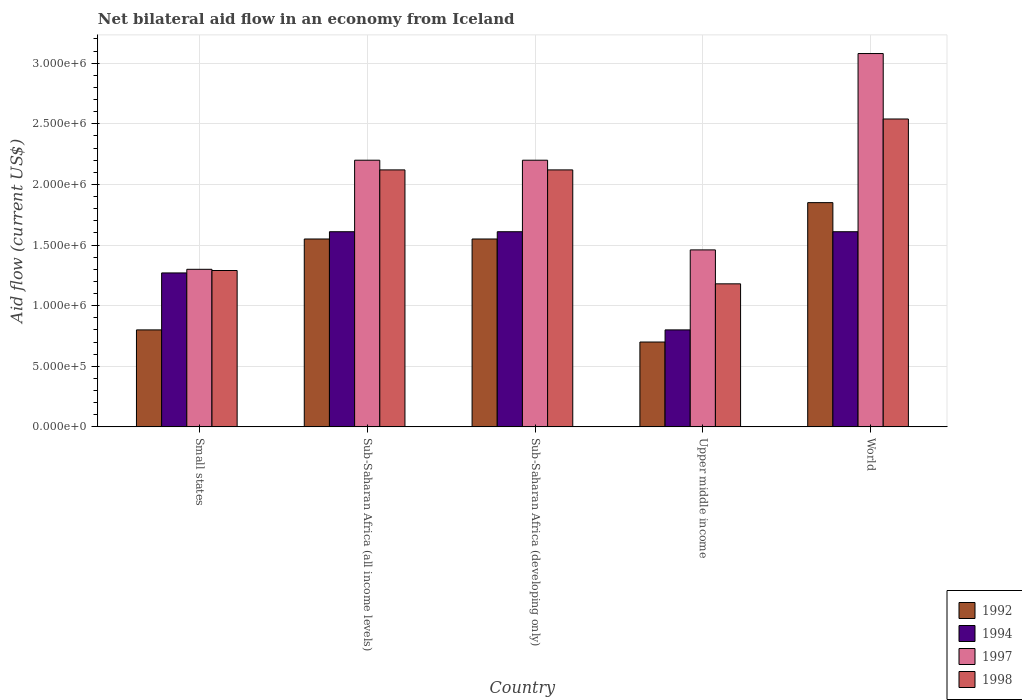How many different coloured bars are there?
Ensure brevity in your answer.  4. How many bars are there on the 4th tick from the left?
Ensure brevity in your answer.  4. What is the label of the 4th group of bars from the left?
Provide a succinct answer. Upper middle income. In how many cases, is the number of bars for a given country not equal to the number of legend labels?
Ensure brevity in your answer.  0. What is the net bilateral aid flow in 1998 in World?
Make the answer very short. 2.54e+06. Across all countries, what is the maximum net bilateral aid flow in 1992?
Offer a very short reply. 1.85e+06. Across all countries, what is the minimum net bilateral aid flow in 1998?
Your answer should be very brief. 1.18e+06. In which country was the net bilateral aid flow in 1997 maximum?
Your response must be concise. World. In which country was the net bilateral aid flow in 1992 minimum?
Your response must be concise. Upper middle income. What is the total net bilateral aid flow in 1998 in the graph?
Offer a very short reply. 9.25e+06. What is the difference between the net bilateral aid flow in 1997 in Sub-Saharan Africa (all income levels) and that in Sub-Saharan Africa (developing only)?
Ensure brevity in your answer.  0. What is the difference between the net bilateral aid flow in 1992 in Sub-Saharan Africa (all income levels) and the net bilateral aid flow in 1998 in Sub-Saharan Africa (developing only)?
Make the answer very short. -5.70e+05. What is the average net bilateral aid flow in 1998 per country?
Offer a terse response. 1.85e+06. What is the difference between the net bilateral aid flow of/in 1998 and net bilateral aid flow of/in 1992 in Sub-Saharan Africa (developing only)?
Your answer should be very brief. 5.70e+05. What is the ratio of the net bilateral aid flow in 1998 in Small states to that in Sub-Saharan Africa (developing only)?
Your response must be concise. 0.61. Is the net bilateral aid flow in 1994 in Upper middle income less than that in World?
Your response must be concise. Yes. What is the difference between the highest and the lowest net bilateral aid flow in 1992?
Give a very brief answer. 1.15e+06. What does the 1st bar from the left in Sub-Saharan Africa (developing only) represents?
Your answer should be compact. 1992. Is it the case that in every country, the sum of the net bilateral aid flow in 1998 and net bilateral aid flow in 1997 is greater than the net bilateral aid flow in 1994?
Give a very brief answer. Yes. Are all the bars in the graph horizontal?
Your answer should be compact. No. Are the values on the major ticks of Y-axis written in scientific E-notation?
Your response must be concise. Yes. How are the legend labels stacked?
Your response must be concise. Vertical. What is the title of the graph?
Your answer should be compact. Net bilateral aid flow in an economy from Iceland. What is the label or title of the X-axis?
Offer a very short reply. Country. What is the Aid flow (current US$) of 1994 in Small states?
Provide a succinct answer. 1.27e+06. What is the Aid flow (current US$) of 1997 in Small states?
Provide a succinct answer. 1.30e+06. What is the Aid flow (current US$) of 1998 in Small states?
Offer a very short reply. 1.29e+06. What is the Aid flow (current US$) of 1992 in Sub-Saharan Africa (all income levels)?
Provide a succinct answer. 1.55e+06. What is the Aid flow (current US$) in 1994 in Sub-Saharan Africa (all income levels)?
Provide a succinct answer. 1.61e+06. What is the Aid flow (current US$) of 1997 in Sub-Saharan Africa (all income levels)?
Your response must be concise. 2.20e+06. What is the Aid flow (current US$) of 1998 in Sub-Saharan Africa (all income levels)?
Your response must be concise. 2.12e+06. What is the Aid flow (current US$) of 1992 in Sub-Saharan Africa (developing only)?
Offer a terse response. 1.55e+06. What is the Aid flow (current US$) of 1994 in Sub-Saharan Africa (developing only)?
Ensure brevity in your answer.  1.61e+06. What is the Aid flow (current US$) of 1997 in Sub-Saharan Africa (developing only)?
Your answer should be very brief. 2.20e+06. What is the Aid flow (current US$) in 1998 in Sub-Saharan Africa (developing only)?
Provide a short and direct response. 2.12e+06. What is the Aid flow (current US$) in 1997 in Upper middle income?
Provide a short and direct response. 1.46e+06. What is the Aid flow (current US$) in 1998 in Upper middle income?
Your answer should be very brief. 1.18e+06. What is the Aid flow (current US$) in 1992 in World?
Your answer should be compact. 1.85e+06. What is the Aid flow (current US$) in 1994 in World?
Ensure brevity in your answer.  1.61e+06. What is the Aid flow (current US$) of 1997 in World?
Keep it short and to the point. 3.08e+06. What is the Aid flow (current US$) of 1998 in World?
Ensure brevity in your answer.  2.54e+06. Across all countries, what is the maximum Aid flow (current US$) of 1992?
Provide a succinct answer. 1.85e+06. Across all countries, what is the maximum Aid flow (current US$) in 1994?
Offer a very short reply. 1.61e+06. Across all countries, what is the maximum Aid flow (current US$) of 1997?
Provide a succinct answer. 3.08e+06. Across all countries, what is the maximum Aid flow (current US$) of 1998?
Make the answer very short. 2.54e+06. Across all countries, what is the minimum Aid flow (current US$) in 1992?
Ensure brevity in your answer.  7.00e+05. Across all countries, what is the minimum Aid flow (current US$) in 1997?
Provide a succinct answer. 1.30e+06. Across all countries, what is the minimum Aid flow (current US$) of 1998?
Offer a very short reply. 1.18e+06. What is the total Aid flow (current US$) in 1992 in the graph?
Offer a very short reply. 6.45e+06. What is the total Aid flow (current US$) of 1994 in the graph?
Provide a short and direct response. 6.90e+06. What is the total Aid flow (current US$) in 1997 in the graph?
Ensure brevity in your answer.  1.02e+07. What is the total Aid flow (current US$) in 1998 in the graph?
Make the answer very short. 9.25e+06. What is the difference between the Aid flow (current US$) in 1992 in Small states and that in Sub-Saharan Africa (all income levels)?
Your response must be concise. -7.50e+05. What is the difference between the Aid flow (current US$) in 1994 in Small states and that in Sub-Saharan Africa (all income levels)?
Your response must be concise. -3.40e+05. What is the difference between the Aid flow (current US$) of 1997 in Small states and that in Sub-Saharan Africa (all income levels)?
Provide a succinct answer. -9.00e+05. What is the difference between the Aid flow (current US$) in 1998 in Small states and that in Sub-Saharan Africa (all income levels)?
Offer a terse response. -8.30e+05. What is the difference between the Aid flow (current US$) in 1992 in Small states and that in Sub-Saharan Africa (developing only)?
Keep it short and to the point. -7.50e+05. What is the difference between the Aid flow (current US$) in 1994 in Small states and that in Sub-Saharan Africa (developing only)?
Your response must be concise. -3.40e+05. What is the difference between the Aid flow (current US$) of 1997 in Small states and that in Sub-Saharan Africa (developing only)?
Your answer should be compact. -9.00e+05. What is the difference between the Aid flow (current US$) of 1998 in Small states and that in Sub-Saharan Africa (developing only)?
Offer a very short reply. -8.30e+05. What is the difference between the Aid flow (current US$) of 1994 in Small states and that in Upper middle income?
Offer a terse response. 4.70e+05. What is the difference between the Aid flow (current US$) in 1997 in Small states and that in Upper middle income?
Provide a short and direct response. -1.60e+05. What is the difference between the Aid flow (current US$) of 1992 in Small states and that in World?
Your response must be concise. -1.05e+06. What is the difference between the Aid flow (current US$) in 1997 in Small states and that in World?
Offer a terse response. -1.78e+06. What is the difference between the Aid flow (current US$) in 1998 in Small states and that in World?
Keep it short and to the point. -1.25e+06. What is the difference between the Aid flow (current US$) of 1992 in Sub-Saharan Africa (all income levels) and that in Sub-Saharan Africa (developing only)?
Make the answer very short. 0. What is the difference between the Aid flow (current US$) in 1994 in Sub-Saharan Africa (all income levels) and that in Sub-Saharan Africa (developing only)?
Offer a very short reply. 0. What is the difference between the Aid flow (current US$) in 1992 in Sub-Saharan Africa (all income levels) and that in Upper middle income?
Your answer should be very brief. 8.50e+05. What is the difference between the Aid flow (current US$) in 1994 in Sub-Saharan Africa (all income levels) and that in Upper middle income?
Your response must be concise. 8.10e+05. What is the difference between the Aid flow (current US$) of 1997 in Sub-Saharan Africa (all income levels) and that in Upper middle income?
Provide a short and direct response. 7.40e+05. What is the difference between the Aid flow (current US$) of 1998 in Sub-Saharan Africa (all income levels) and that in Upper middle income?
Make the answer very short. 9.40e+05. What is the difference between the Aid flow (current US$) in 1997 in Sub-Saharan Africa (all income levels) and that in World?
Ensure brevity in your answer.  -8.80e+05. What is the difference between the Aid flow (current US$) of 1998 in Sub-Saharan Africa (all income levels) and that in World?
Your response must be concise. -4.20e+05. What is the difference between the Aid flow (current US$) in 1992 in Sub-Saharan Africa (developing only) and that in Upper middle income?
Your answer should be compact. 8.50e+05. What is the difference between the Aid flow (current US$) in 1994 in Sub-Saharan Africa (developing only) and that in Upper middle income?
Your answer should be very brief. 8.10e+05. What is the difference between the Aid flow (current US$) in 1997 in Sub-Saharan Africa (developing only) and that in Upper middle income?
Ensure brevity in your answer.  7.40e+05. What is the difference between the Aid flow (current US$) in 1998 in Sub-Saharan Africa (developing only) and that in Upper middle income?
Provide a succinct answer. 9.40e+05. What is the difference between the Aid flow (current US$) in 1992 in Sub-Saharan Africa (developing only) and that in World?
Keep it short and to the point. -3.00e+05. What is the difference between the Aid flow (current US$) of 1994 in Sub-Saharan Africa (developing only) and that in World?
Keep it short and to the point. 0. What is the difference between the Aid flow (current US$) in 1997 in Sub-Saharan Africa (developing only) and that in World?
Keep it short and to the point. -8.80e+05. What is the difference between the Aid flow (current US$) in 1998 in Sub-Saharan Africa (developing only) and that in World?
Your answer should be compact. -4.20e+05. What is the difference between the Aid flow (current US$) of 1992 in Upper middle income and that in World?
Offer a very short reply. -1.15e+06. What is the difference between the Aid flow (current US$) of 1994 in Upper middle income and that in World?
Your answer should be compact. -8.10e+05. What is the difference between the Aid flow (current US$) in 1997 in Upper middle income and that in World?
Provide a short and direct response. -1.62e+06. What is the difference between the Aid flow (current US$) in 1998 in Upper middle income and that in World?
Provide a succinct answer. -1.36e+06. What is the difference between the Aid flow (current US$) of 1992 in Small states and the Aid flow (current US$) of 1994 in Sub-Saharan Africa (all income levels)?
Make the answer very short. -8.10e+05. What is the difference between the Aid flow (current US$) of 1992 in Small states and the Aid flow (current US$) of 1997 in Sub-Saharan Africa (all income levels)?
Keep it short and to the point. -1.40e+06. What is the difference between the Aid flow (current US$) in 1992 in Small states and the Aid flow (current US$) in 1998 in Sub-Saharan Africa (all income levels)?
Offer a very short reply. -1.32e+06. What is the difference between the Aid flow (current US$) of 1994 in Small states and the Aid flow (current US$) of 1997 in Sub-Saharan Africa (all income levels)?
Provide a succinct answer. -9.30e+05. What is the difference between the Aid flow (current US$) in 1994 in Small states and the Aid flow (current US$) in 1998 in Sub-Saharan Africa (all income levels)?
Give a very brief answer. -8.50e+05. What is the difference between the Aid flow (current US$) of 1997 in Small states and the Aid flow (current US$) of 1998 in Sub-Saharan Africa (all income levels)?
Ensure brevity in your answer.  -8.20e+05. What is the difference between the Aid flow (current US$) in 1992 in Small states and the Aid flow (current US$) in 1994 in Sub-Saharan Africa (developing only)?
Ensure brevity in your answer.  -8.10e+05. What is the difference between the Aid flow (current US$) in 1992 in Small states and the Aid flow (current US$) in 1997 in Sub-Saharan Africa (developing only)?
Offer a terse response. -1.40e+06. What is the difference between the Aid flow (current US$) in 1992 in Small states and the Aid flow (current US$) in 1998 in Sub-Saharan Africa (developing only)?
Ensure brevity in your answer.  -1.32e+06. What is the difference between the Aid flow (current US$) of 1994 in Small states and the Aid flow (current US$) of 1997 in Sub-Saharan Africa (developing only)?
Your response must be concise. -9.30e+05. What is the difference between the Aid flow (current US$) in 1994 in Small states and the Aid flow (current US$) in 1998 in Sub-Saharan Africa (developing only)?
Keep it short and to the point. -8.50e+05. What is the difference between the Aid flow (current US$) of 1997 in Small states and the Aid flow (current US$) of 1998 in Sub-Saharan Africa (developing only)?
Provide a succinct answer. -8.20e+05. What is the difference between the Aid flow (current US$) of 1992 in Small states and the Aid flow (current US$) of 1994 in Upper middle income?
Make the answer very short. 0. What is the difference between the Aid flow (current US$) in 1992 in Small states and the Aid flow (current US$) in 1997 in Upper middle income?
Offer a terse response. -6.60e+05. What is the difference between the Aid flow (current US$) in 1992 in Small states and the Aid flow (current US$) in 1998 in Upper middle income?
Make the answer very short. -3.80e+05. What is the difference between the Aid flow (current US$) in 1997 in Small states and the Aid flow (current US$) in 1998 in Upper middle income?
Your response must be concise. 1.20e+05. What is the difference between the Aid flow (current US$) of 1992 in Small states and the Aid flow (current US$) of 1994 in World?
Make the answer very short. -8.10e+05. What is the difference between the Aid flow (current US$) in 1992 in Small states and the Aid flow (current US$) in 1997 in World?
Keep it short and to the point. -2.28e+06. What is the difference between the Aid flow (current US$) of 1992 in Small states and the Aid flow (current US$) of 1998 in World?
Your answer should be very brief. -1.74e+06. What is the difference between the Aid flow (current US$) in 1994 in Small states and the Aid flow (current US$) in 1997 in World?
Your answer should be compact. -1.81e+06. What is the difference between the Aid flow (current US$) in 1994 in Small states and the Aid flow (current US$) in 1998 in World?
Your answer should be compact. -1.27e+06. What is the difference between the Aid flow (current US$) in 1997 in Small states and the Aid flow (current US$) in 1998 in World?
Give a very brief answer. -1.24e+06. What is the difference between the Aid flow (current US$) in 1992 in Sub-Saharan Africa (all income levels) and the Aid flow (current US$) in 1997 in Sub-Saharan Africa (developing only)?
Offer a very short reply. -6.50e+05. What is the difference between the Aid flow (current US$) of 1992 in Sub-Saharan Africa (all income levels) and the Aid flow (current US$) of 1998 in Sub-Saharan Africa (developing only)?
Ensure brevity in your answer.  -5.70e+05. What is the difference between the Aid flow (current US$) of 1994 in Sub-Saharan Africa (all income levels) and the Aid flow (current US$) of 1997 in Sub-Saharan Africa (developing only)?
Your answer should be very brief. -5.90e+05. What is the difference between the Aid flow (current US$) in 1994 in Sub-Saharan Africa (all income levels) and the Aid flow (current US$) in 1998 in Sub-Saharan Africa (developing only)?
Offer a very short reply. -5.10e+05. What is the difference between the Aid flow (current US$) in 1997 in Sub-Saharan Africa (all income levels) and the Aid flow (current US$) in 1998 in Sub-Saharan Africa (developing only)?
Ensure brevity in your answer.  8.00e+04. What is the difference between the Aid flow (current US$) of 1992 in Sub-Saharan Africa (all income levels) and the Aid flow (current US$) of 1994 in Upper middle income?
Your answer should be very brief. 7.50e+05. What is the difference between the Aid flow (current US$) of 1992 in Sub-Saharan Africa (all income levels) and the Aid flow (current US$) of 1998 in Upper middle income?
Make the answer very short. 3.70e+05. What is the difference between the Aid flow (current US$) of 1994 in Sub-Saharan Africa (all income levels) and the Aid flow (current US$) of 1997 in Upper middle income?
Give a very brief answer. 1.50e+05. What is the difference between the Aid flow (current US$) of 1994 in Sub-Saharan Africa (all income levels) and the Aid flow (current US$) of 1998 in Upper middle income?
Give a very brief answer. 4.30e+05. What is the difference between the Aid flow (current US$) in 1997 in Sub-Saharan Africa (all income levels) and the Aid flow (current US$) in 1998 in Upper middle income?
Ensure brevity in your answer.  1.02e+06. What is the difference between the Aid flow (current US$) in 1992 in Sub-Saharan Africa (all income levels) and the Aid flow (current US$) in 1994 in World?
Provide a short and direct response. -6.00e+04. What is the difference between the Aid flow (current US$) of 1992 in Sub-Saharan Africa (all income levels) and the Aid flow (current US$) of 1997 in World?
Your response must be concise. -1.53e+06. What is the difference between the Aid flow (current US$) in 1992 in Sub-Saharan Africa (all income levels) and the Aid flow (current US$) in 1998 in World?
Ensure brevity in your answer.  -9.90e+05. What is the difference between the Aid flow (current US$) of 1994 in Sub-Saharan Africa (all income levels) and the Aid flow (current US$) of 1997 in World?
Provide a succinct answer. -1.47e+06. What is the difference between the Aid flow (current US$) of 1994 in Sub-Saharan Africa (all income levels) and the Aid flow (current US$) of 1998 in World?
Your response must be concise. -9.30e+05. What is the difference between the Aid flow (current US$) in 1997 in Sub-Saharan Africa (all income levels) and the Aid flow (current US$) in 1998 in World?
Offer a terse response. -3.40e+05. What is the difference between the Aid flow (current US$) in 1992 in Sub-Saharan Africa (developing only) and the Aid flow (current US$) in 1994 in Upper middle income?
Your response must be concise. 7.50e+05. What is the difference between the Aid flow (current US$) in 1992 in Sub-Saharan Africa (developing only) and the Aid flow (current US$) in 1997 in Upper middle income?
Offer a terse response. 9.00e+04. What is the difference between the Aid flow (current US$) in 1992 in Sub-Saharan Africa (developing only) and the Aid flow (current US$) in 1998 in Upper middle income?
Keep it short and to the point. 3.70e+05. What is the difference between the Aid flow (current US$) in 1994 in Sub-Saharan Africa (developing only) and the Aid flow (current US$) in 1997 in Upper middle income?
Your answer should be compact. 1.50e+05. What is the difference between the Aid flow (current US$) in 1994 in Sub-Saharan Africa (developing only) and the Aid flow (current US$) in 1998 in Upper middle income?
Provide a short and direct response. 4.30e+05. What is the difference between the Aid flow (current US$) of 1997 in Sub-Saharan Africa (developing only) and the Aid flow (current US$) of 1998 in Upper middle income?
Offer a very short reply. 1.02e+06. What is the difference between the Aid flow (current US$) of 1992 in Sub-Saharan Africa (developing only) and the Aid flow (current US$) of 1997 in World?
Ensure brevity in your answer.  -1.53e+06. What is the difference between the Aid flow (current US$) in 1992 in Sub-Saharan Africa (developing only) and the Aid flow (current US$) in 1998 in World?
Make the answer very short. -9.90e+05. What is the difference between the Aid flow (current US$) of 1994 in Sub-Saharan Africa (developing only) and the Aid flow (current US$) of 1997 in World?
Ensure brevity in your answer.  -1.47e+06. What is the difference between the Aid flow (current US$) of 1994 in Sub-Saharan Africa (developing only) and the Aid flow (current US$) of 1998 in World?
Offer a very short reply. -9.30e+05. What is the difference between the Aid flow (current US$) of 1997 in Sub-Saharan Africa (developing only) and the Aid flow (current US$) of 1998 in World?
Make the answer very short. -3.40e+05. What is the difference between the Aid flow (current US$) in 1992 in Upper middle income and the Aid flow (current US$) in 1994 in World?
Provide a short and direct response. -9.10e+05. What is the difference between the Aid flow (current US$) in 1992 in Upper middle income and the Aid flow (current US$) in 1997 in World?
Keep it short and to the point. -2.38e+06. What is the difference between the Aid flow (current US$) of 1992 in Upper middle income and the Aid flow (current US$) of 1998 in World?
Keep it short and to the point. -1.84e+06. What is the difference between the Aid flow (current US$) of 1994 in Upper middle income and the Aid flow (current US$) of 1997 in World?
Your answer should be very brief. -2.28e+06. What is the difference between the Aid flow (current US$) of 1994 in Upper middle income and the Aid flow (current US$) of 1998 in World?
Make the answer very short. -1.74e+06. What is the difference between the Aid flow (current US$) in 1997 in Upper middle income and the Aid flow (current US$) in 1998 in World?
Your answer should be compact. -1.08e+06. What is the average Aid flow (current US$) in 1992 per country?
Provide a succinct answer. 1.29e+06. What is the average Aid flow (current US$) of 1994 per country?
Provide a short and direct response. 1.38e+06. What is the average Aid flow (current US$) in 1997 per country?
Keep it short and to the point. 2.05e+06. What is the average Aid flow (current US$) of 1998 per country?
Provide a short and direct response. 1.85e+06. What is the difference between the Aid flow (current US$) of 1992 and Aid flow (current US$) of 1994 in Small states?
Make the answer very short. -4.70e+05. What is the difference between the Aid flow (current US$) in 1992 and Aid flow (current US$) in 1997 in Small states?
Provide a short and direct response. -5.00e+05. What is the difference between the Aid flow (current US$) in 1992 and Aid flow (current US$) in 1998 in Small states?
Make the answer very short. -4.90e+05. What is the difference between the Aid flow (current US$) of 1994 and Aid flow (current US$) of 1998 in Small states?
Keep it short and to the point. -2.00e+04. What is the difference between the Aid flow (current US$) in 1992 and Aid flow (current US$) in 1997 in Sub-Saharan Africa (all income levels)?
Give a very brief answer. -6.50e+05. What is the difference between the Aid flow (current US$) of 1992 and Aid flow (current US$) of 1998 in Sub-Saharan Africa (all income levels)?
Offer a terse response. -5.70e+05. What is the difference between the Aid flow (current US$) of 1994 and Aid flow (current US$) of 1997 in Sub-Saharan Africa (all income levels)?
Your answer should be compact. -5.90e+05. What is the difference between the Aid flow (current US$) of 1994 and Aid flow (current US$) of 1998 in Sub-Saharan Africa (all income levels)?
Your response must be concise. -5.10e+05. What is the difference between the Aid flow (current US$) of 1992 and Aid flow (current US$) of 1994 in Sub-Saharan Africa (developing only)?
Your response must be concise. -6.00e+04. What is the difference between the Aid flow (current US$) of 1992 and Aid flow (current US$) of 1997 in Sub-Saharan Africa (developing only)?
Make the answer very short. -6.50e+05. What is the difference between the Aid flow (current US$) in 1992 and Aid flow (current US$) in 1998 in Sub-Saharan Africa (developing only)?
Ensure brevity in your answer.  -5.70e+05. What is the difference between the Aid flow (current US$) in 1994 and Aid flow (current US$) in 1997 in Sub-Saharan Africa (developing only)?
Provide a short and direct response. -5.90e+05. What is the difference between the Aid flow (current US$) of 1994 and Aid flow (current US$) of 1998 in Sub-Saharan Africa (developing only)?
Your answer should be very brief. -5.10e+05. What is the difference between the Aid flow (current US$) in 1997 and Aid flow (current US$) in 1998 in Sub-Saharan Africa (developing only)?
Give a very brief answer. 8.00e+04. What is the difference between the Aid flow (current US$) in 1992 and Aid flow (current US$) in 1994 in Upper middle income?
Your answer should be compact. -1.00e+05. What is the difference between the Aid flow (current US$) in 1992 and Aid flow (current US$) in 1997 in Upper middle income?
Make the answer very short. -7.60e+05. What is the difference between the Aid flow (current US$) in 1992 and Aid flow (current US$) in 1998 in Upper middle income?
Your response must be concise. -4.80e+05. What is the difference between the Aid flow (current US$) in 1994 and Aid flow (current US$) in 1997 in Upper middle income?
Ensure brevity in your answer.  -6.60e+05. What is the difference between the Aid flow (current US$) in 1994 and Aid flow (current US$) in 1998 in Upper middle income?
Your answer should be very brief. -3.80e+05. What is the difference between the Aid flow (current US$) in 1992 and Aid flow (current US$) in 1994 in World?
Make the answer very short. 2.40e+05. What is the difference between the Aid flow (current US$) of 1992 and Aid flow (current US$) of 1997 in World?
Offer a very short reply. -1.23e+06. What is the difference between the Aid flow (current US$) of 1992 and Aid flow (current US$) of 1998 in World?
Make the answer very short. -6.90e+05. What is the difference between the Aid flow (current US$) of 1994 and Aid flow (current US$) of 1997 in World?
Offer a terse response. -1.47e+06. What is the difference between the Aid flow (current US$) of 1994 and Aid flow (current US$) of 1998 in World?
Provide a short and direct response. -9.30e+05. What is the difference between the Aid flow (current US$) in 1997 and Aid flow (current US$) in 1998 in World?
Your answer should be compact. 5.40e+05. What is the ratio of the Aid flow (current US$) of 1992 in Small states to that in Sub-Saharan Africa (all income levels)?
Ensure brevity in your answer.  0.52. What is the ratio of the Aid flow (current US$) in 1994 in Small states to that in Sub-Saharan Africa (all income levels)?
Keep it short and to the point. 0.79. What is the ratio of the Aid flow (current US$) in 1997 in Small states to that in Sub-Saharan Africa (all income levels)?
Offer a very short reply. 0.59. What is the ratio of the Aid flow (current US$) in 1998 in Small states to that in Sub-Saharan Africa (all income levels)?
Your answer should be compact. 0.61. What is the ratio of the Aid flow (current US$) of 1992 in Small states to that in Sub-Saharan Africa (developing only)?
Your response must be concise. 0.52. What is the ratio of the Aid flow (current US$) of 1994 in Small states to that in Sub-Saharan Africa (developing only)?
Keep it short and to the point. 0.79. What is the ratio of the Aid flow (current US$) in 1997 in Small states to that in Sub-Saharan Africa (developing only)?
Give a very brief answer. 0.59. What is the ratio of the Aid flow (current US$) of 1998 in Small states to that in Sub-Saharan Africa (developing only)?
Provide a succinct answer. 0.61. What is the ratio of the Aid flow (current US$) in 1992 in Small states to that in Upper middle income?
Provide a succinct answer. 1.14. What is the ratio of the Aid flow (current US$) of 1994 in Small states to that in Upper middle income?
Offer a terse response. 1.59. What is the ratio of the Aid flow (current US$) of 1997 in Small states to that in Upper middle income?
Provide a succinct answer. 0.89. What is the ratio of the Aid flow (current US$) of 1998 in Small states to that in Upper middle income?
Give a very brief answer. 1.09. What is the ratio of the Aid flow (current US$) of 1992 in Small states to that in World?
Provide a short and direct response. 0.43. What is the ratio of the Aid flow (current US$) of 1994 in Small states to that in World?
Keep it short and to the point. 0.79. What is the ratio of the Aid flow (current US$) of 1997 in Small states to that in World?
Provide a short and direct response. 0.42. What is the ratio of the Aid flow (current US$) of 1998 in Small states to that in World?
Your answer should be very brief. 0.51. What is the ratio of the Aid flow (current US$) of 1992 in Sub-Saharan Africa (all income levels) to that in Sub-Saharan Africa (developing only)?
Keep it short and to the point. 1. What is the ratio of the Aid flow (current US$) in 1994 in Sub-Saharan Africa (all income levels) to that in Sub-Saharan Africa (developing only)?
Ensure brevity in your answer.  1. What is the ratio of the Aid flow (current US$) in 1998 in Sub-Saharan Africa (all income levels) to that in Sub-Saharan Africa (developing only)?
Provide a succinct answer. 1. What is the ratio of the Aid flow (current US$) of 1992 in Sub-Saharan Africa (all income levels) to that in Upper middle income?
Keep it short and to the point. 2.21. What is the ratio of the Aid flow (current US$) of 1994 in Sub-Saharan Africa (all income levels) to that in Upper middle income?
Keep it short and to the point. 2.01. What is the ratio of the Aid flow (current US$) of 1997 in Sub-Saharan Africa (all income levels) to that in Upper middle income?
Give a very brief answer. 1.51. What is the ratio of the Aid flow (current US$) of 1998 in Sub-Saharan Africa (all income levels) to that in Upper middle income?
Offer a very short reply. 1.8. What is the ratio of the Aid flow (current US$) in 1992 in Sub-Saharan Africa (all income levels) to that in World?
Make the answer very short. 0.84. What is the ratio of the Aid flow (current US$) of 1994 in Sub-Saharan Africa (all income levels) to that in World?
Offer a terse response. 1. What is the ratio of the Aid flow (current US$) of 1997 in Sub-Saharan Africa (all income levels) to that in World?
Give a very brief answer. 0.71. What is the ratio of the Aid flow (current US$) in 1998 in Sub-Saharan Africa (all income levels) to that in World?
Your answer should be compact. 0.83. What is the ratio of the Aid flow (current US$) in 1992 in Sub-Saharan Africa (developing only) to that in Upper middle income?
Your response must be concise. 2.21. What is the ratio of the Aid flow (current US$) of 1994 in Sub-Saharan Africa (developing only) to that in Upper middle income?
Give a very brief answer. 2.01. What is the ratio of the Aid flow (current US$) in 1997 in Sub-Saharan Africa (developing only) to that in Upper middle income?
Provide a succinct answer. 1.51. What is the ratio of the Aid flow (current US$) of 1998 in Sub-Saharan Africa (developing only) to that in Upper middle income?
Your answer should be very brief. 1.8. What is the ratio of the Aid flow (current US$) in 1992 in Sub-Saharan Africa (developing only) to that in World?
Make the answer very short. 0.84. What is the ratio of the Aid flow (current US$) of 1997 in Sub-Saharan Africa (developing only) to that in World?
Ensure brevity in your answer.  0.71. What is the ratio of the Aid flow (current US$) in 1998 in Sub-Saharan Africa (developing only) to that in World?
Your answer should be very brief. 0.83. What is the ratio of the Aid flow (current US$) of 1992 in Upper middle income to that in World?
Your answer should be very brief. 0.38. What is the ratio of the Aid flow (current US$) of 1994 in Upper middle income to that in World?
Provide a succinct answer. 0.5. What is the ratio of the Aid flow (current US$) in 1997 in Upper middle income to that in World?
Your answer should be very brief. 0.47. What is the ratio of the Aid flow (current US$) in 1998 in Upper middle income to that in World?
Your answer should be compact. 0.46. What is the difference between the highest and the second highest Aid flow (current US$) in 1992?
Keep it short and to the point. 3.00e+05. What is the difference between the highest and the second highest Aid flow (current US$) in 1994?
Your answer should be compact. 0. What is the difference between the highest and the second highest Aid flow (current US$) of 1997?
Offer a terse response. 8.80e+05. What is the difference between the highest and the second highest Aid flow (current US$) of 1998?
Keep it short and to the point. 4.20e+05. What is the difference between the highest and the lowest Aid flow (current US$) of 1992?
Make the answer very short. 1.15e+06. What is the difference between the highest and the lowest Aid flow (current US$) in 1994?
Provide a succinct answer. 8.10e+05. What is the difference between the highest and the lowest Aid flow (current US$) of 1997?
Your answer should be compact. 1.78e+06. What is the difference between the highest and the lowest Aid flow (current US$) of 1998?
Provide a short and direct response. 1.36e+06. 